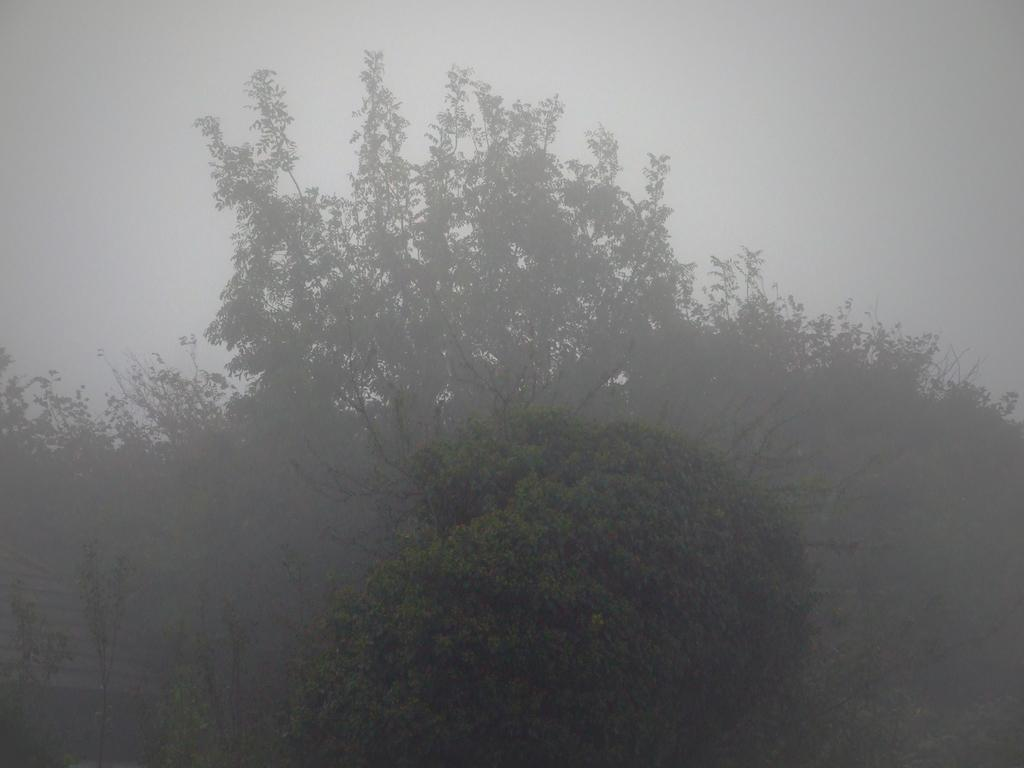What type of vegetation can be seen in the image? There are trees in the image. What type of fruit can be seen hanging from the trees in the image? There is no fruit visible in the image; only trees are present. 